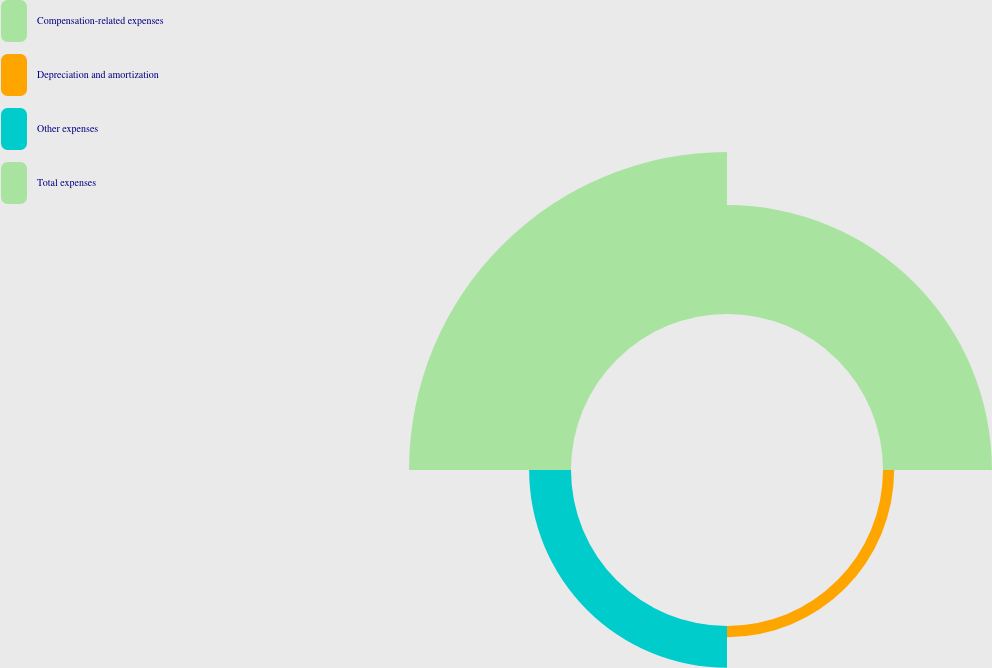Convert chart. <chart><loc_0><loc_0><loc_500><loc_500><pie_chart><fcel>Compensation-related expenses<fcel>Depreciation and amortization<fcel>Other expenses<fcel>Total expenses<nl><fcel>33.62%<fcel>3.45%<fcel>12.92%<fcel>50.0%<nl></chart> 